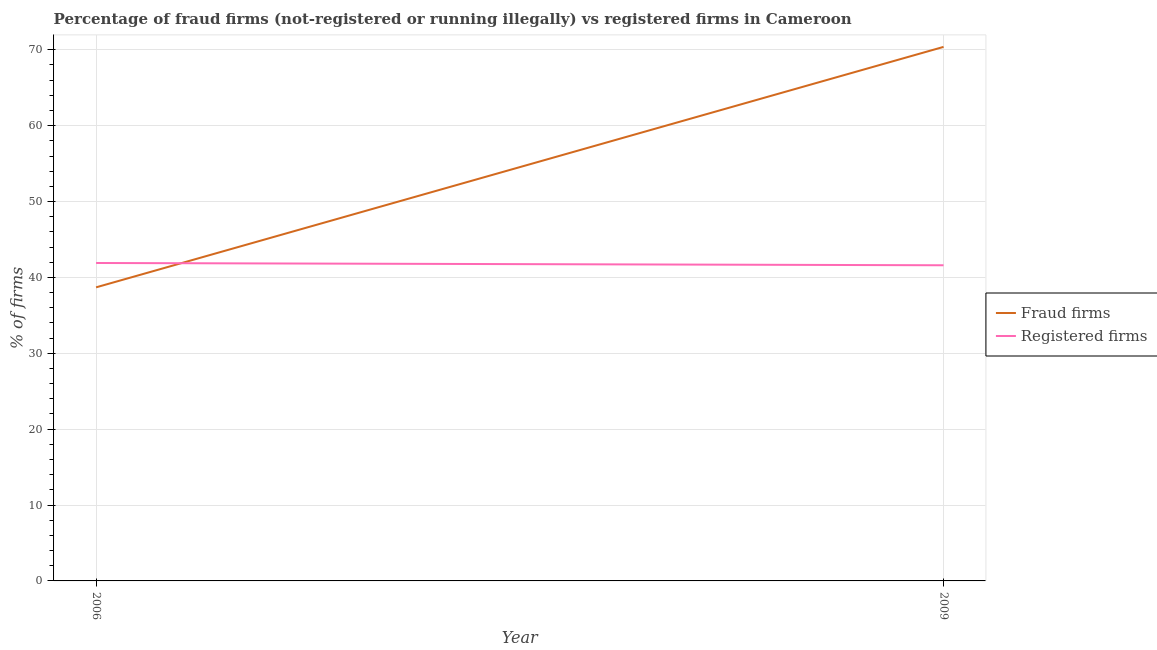Does the line corresponding to percentage of fraud firms intersect with the line corresponding to percentage of registered firms?
Offer a very short reply. Yes. Is the number of lines equal to the number of legend labels?
Provide a succinct answer. Yes. What is the percentage of fraud firms in 2006?
Provide a succinct answer. 38.69. Across all years, what is the maximum percentage of fraud firms?
Keep it short and to the point. 70.38. Across all years, what is the minimum percentage of fraud firms?
Your response must be concise. 38.69. In which year was the percentage of fraud firms maximum?
Your answer should be very brief. 2009. In which year was the percentage of registered firms minimum?
Offer a terse response. 2009. What is the total percentage of registered firms in the graph?
Provide a succinct answer. 83.5. What is the difference between the percentage of fraud firms in 2006 and that in 2009?
Make the answer very short. -31.69. What is the difference between the percentage of fraud firms in 2009 and the percentage of registered firms in 2006?
Your answer should be very brief. 28.48. What is the average percentage of fraud firms per year?
Offer a terse response. 54.53. In the year 2009, what is the difference between the percentage of fraud firms and percentage of registered firms?
Keep it short and to the point. 28.78. What is the ratio of the percentage of fraud firms in 2006 to that in 2009?
Your answer should be compact. 0.55. Does the percentage of registered firms monotonically increase over the years?
Your answer should be very brief. No. Is the percentage of fraud firms strictly greater than the percentage of registered firms over the years?
Keep it short and to the point. No. Is the percentage of fraud firms strictly less than the percentage of registered firms over the years?
Give a very brief answer. No. How many years are there in the graph?
Offer a very short reply. 2. Where does the legend appear in the graph?
Give a very brief answer. Center right. How are the legend labels stacked?
Offer a very short reply. Vertical. What is the title of the graph?
Keep it short and to the point. Percentage of fraud firms (not-registered or running illegally) vs registered firms in Cameroon. Does "Methane" appear as one of the legend labels in the graph?
Your answer should be compact. No. What is the label or title of the X-axis?
Give a very brief answer. Year. What is the label or title of the Y-axis?
Provide a short and direct response. % of firms. What is the % of firms in Fraud firms in 2006?
Your answer should be very brief. 38.69. What is the % of firms in Registered firms in 2006?
Ensure brevity in your answer.  41.9. What is the % of firms of Fraud firms in 2009?
Keep it short and to the point. 70.38. What is the % of firms of Registered firms in 2009?
Keep it short and to the point. 41.6. Across all years, what is the maximum % of firms of Fraud firms?
Ensure brevity in your answer.  70.38. Across all years, what is the maximum % of firms in Registered firms?
Offer a very short reply. 41.9. Across all years, what is the minimum % of firms in Fraud firms?
Your answer should be compact. 38.69. Across all years, what is the minimum % of firms in Registered firms?
Offer a terse response. 41.6. What is the total % of firms of Fraud firms in the graph?
Give a very brief answer. 109.07. What is the total % of firms of Registered firms in the graph?
Offer a terse response. 83.5. What is the difference between the % of firms in Fraud firms in 2006 and that in 2009?
Your answer should be very brief. -31.69. What is the difference between the % of firms of Registered firms in 2006 and that in 2009?
Keep it short and to the point. 0.3. What is the difference between the % of firms in Fraud firms in 2006 and the % of firms in Registered firms in 2009?
Your response must be concise. -2.91. What is the average % of firms of Fraud firms per year?
Provide a succinct answer. 54.53. What is the average % of firms of Registered firms per year?
Ensure brevity in your answer.  41.75. In the year 2006, what is the difference between the % of firms in Fraud firms and % of firms in Registered firms?
Offer a terse response. -3.21. In the year 2009, what is the difference between the % of firms in Fraud firms and % of firms in Registered firms?
Provide a succinct answer. 28.78. What is the ratio of the % of firms in Fraud firms in 2006 to that in 2009?
Keep it short and to the point. 0.55. What is the difference between the highest and the second highest % of firms of Fraud firms?
Your answer should be compact. 31.69. What is the difference between the highest and the lowest % of firms of Fraud firms?
Give a very brief answer. 31.69. What is the difference between the highest and the lowest % of firms in Registered firms?
Your answer should be compact. 0.3. 